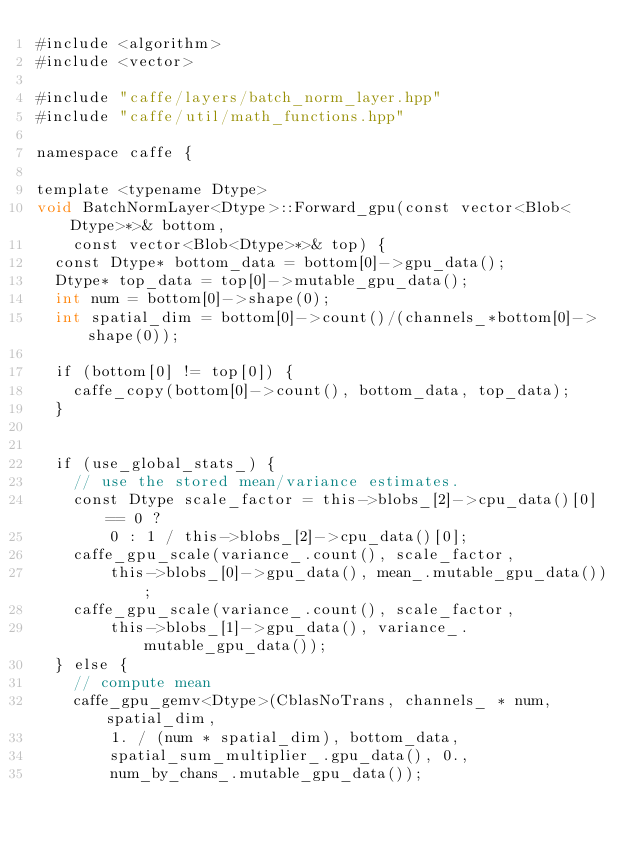<code> <loc_0><loc_0><loc_500><loc_500><_Cuda_>#include <algorithm>
#include <vector>

#include "caffe/layers/batch_norm_layer.hpp"
#include "caffe/util/math_functions.hpp"

namespace caffe {

template <typename Dtype>
void BatchNormLayer<Dtype>::Forward_gpu(const vector<Blob<Dtype>*>& bottom,
    const vector<Blob<Dtype>*>& top) {
  const Dtype* bottom_data = bottom[0]->gpu_data();
  Dtype* top_data = top[0]->mutable_gpu_data();
  int num = bottom[0]->shape(0);
  int spatial_dim = bottom[0]->count()/(channels_*bottom[0]->shape(0));

  if (bottom[0] != top[0]) {
    caffe_copy(bottom[0]->count(), bottom_data, top_data);
  }


  if (use_global_stats_) {
    // use the stored mean/variance estimates.
    const Dtype scale_factor = this->blobs_[2]->cpu_data()[0] == 0 ?
        0 : 1 / this->blobs_[2]->cpu_data()[0];
    caffe_gpu_scale(variance_.count(), scale_factor,
        this->blobs_[0]->gpu_data(), mean_.mutable_gpu_data());
    caffe_gpu_scale(variance_.count(), scale_factor,
        this->blobs_[1]->gpu_data(), variance_.mutable_gpu_data());
  } else {
    // compute mean
    caffe_gpu_gemv<Dtype>(CblasNoTrans, channels_ * num, spatial_dim,
        1. / (num * spatial_dim), bottom_data,
        spatial_sum_multiplier_.gpu_data(), 0.,
        num_by_chans_.mutable_gpu_data());</code> 